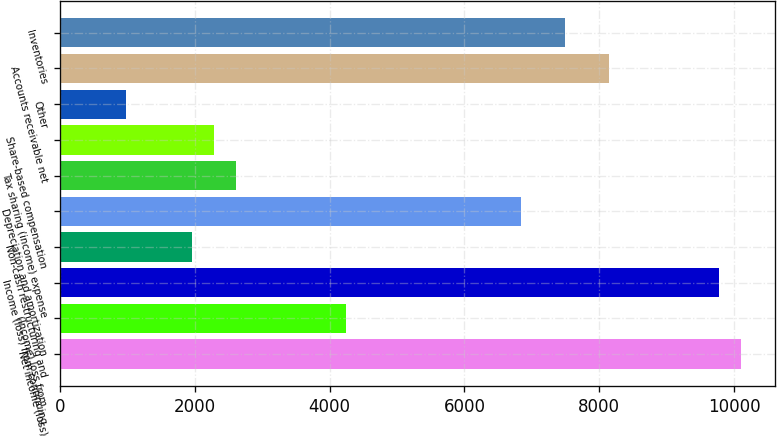Convert chart. <chart><loc_0><loc_0><loc_500><loc_500><bar_chart><fcel>Net income (loss)<fcel>(Income) loss from<fcel>Income (loss) from continuing<fcel>Non-cash restructuring and<fcel>Depreciation and amortization<fcel>Tax sharing (income) expense<fcel>Share-based compensation<fcel>Other<fcel>Accounts receivable net<fcel>Inventories<nl><fcel>10100.8<fcel>4236.4<fcel>9775<fcel>1955.8<fcel>6842.8<fcel>2607.4<fcel>2281.6<fcel>978.4<fcel>8146<fcel>7494.4<nl></chart> 